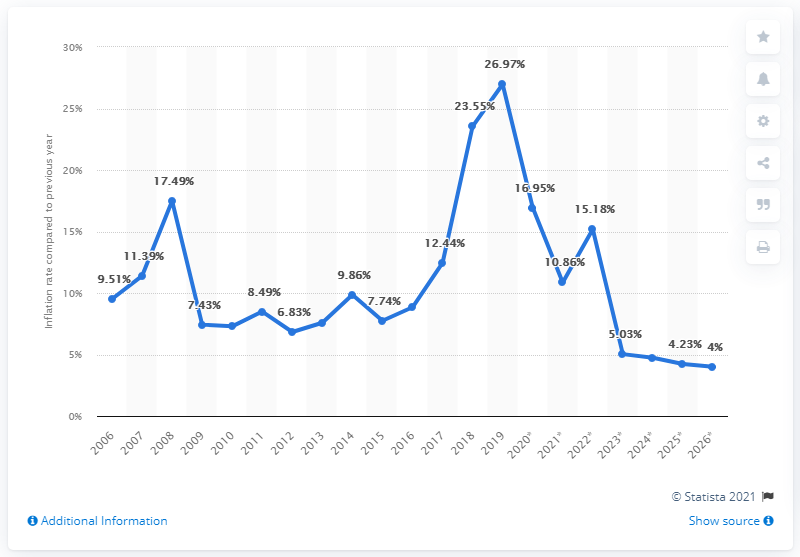Specify some key components in this picture. In 2006, the average inflation rate in Liberia was X. 